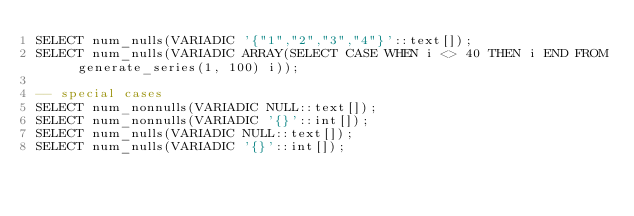Convert code to text. <code><loc_0><loc_0><loc_500><loc_500><_SQL_>SELECT num_nulls(VARIADIC '{"1","2","3","4"}'::text[]);
SELECT num_nulls(VARIADIC ARRAY(SELECT CASE WHEN i <> 40 THEN i END FROM generate_series(1, 100) i));

-- special cases
SELECT num_nonnulls(VARIADIC NULL::text[]);
SELECT num_nonnulls(VARIADIC '{}'::int[]);
SELECT num_nulls(VARIADIC NULL::text[]);
SELECT num_nulls(VARIADIC '{}'::int[]);
</code> 